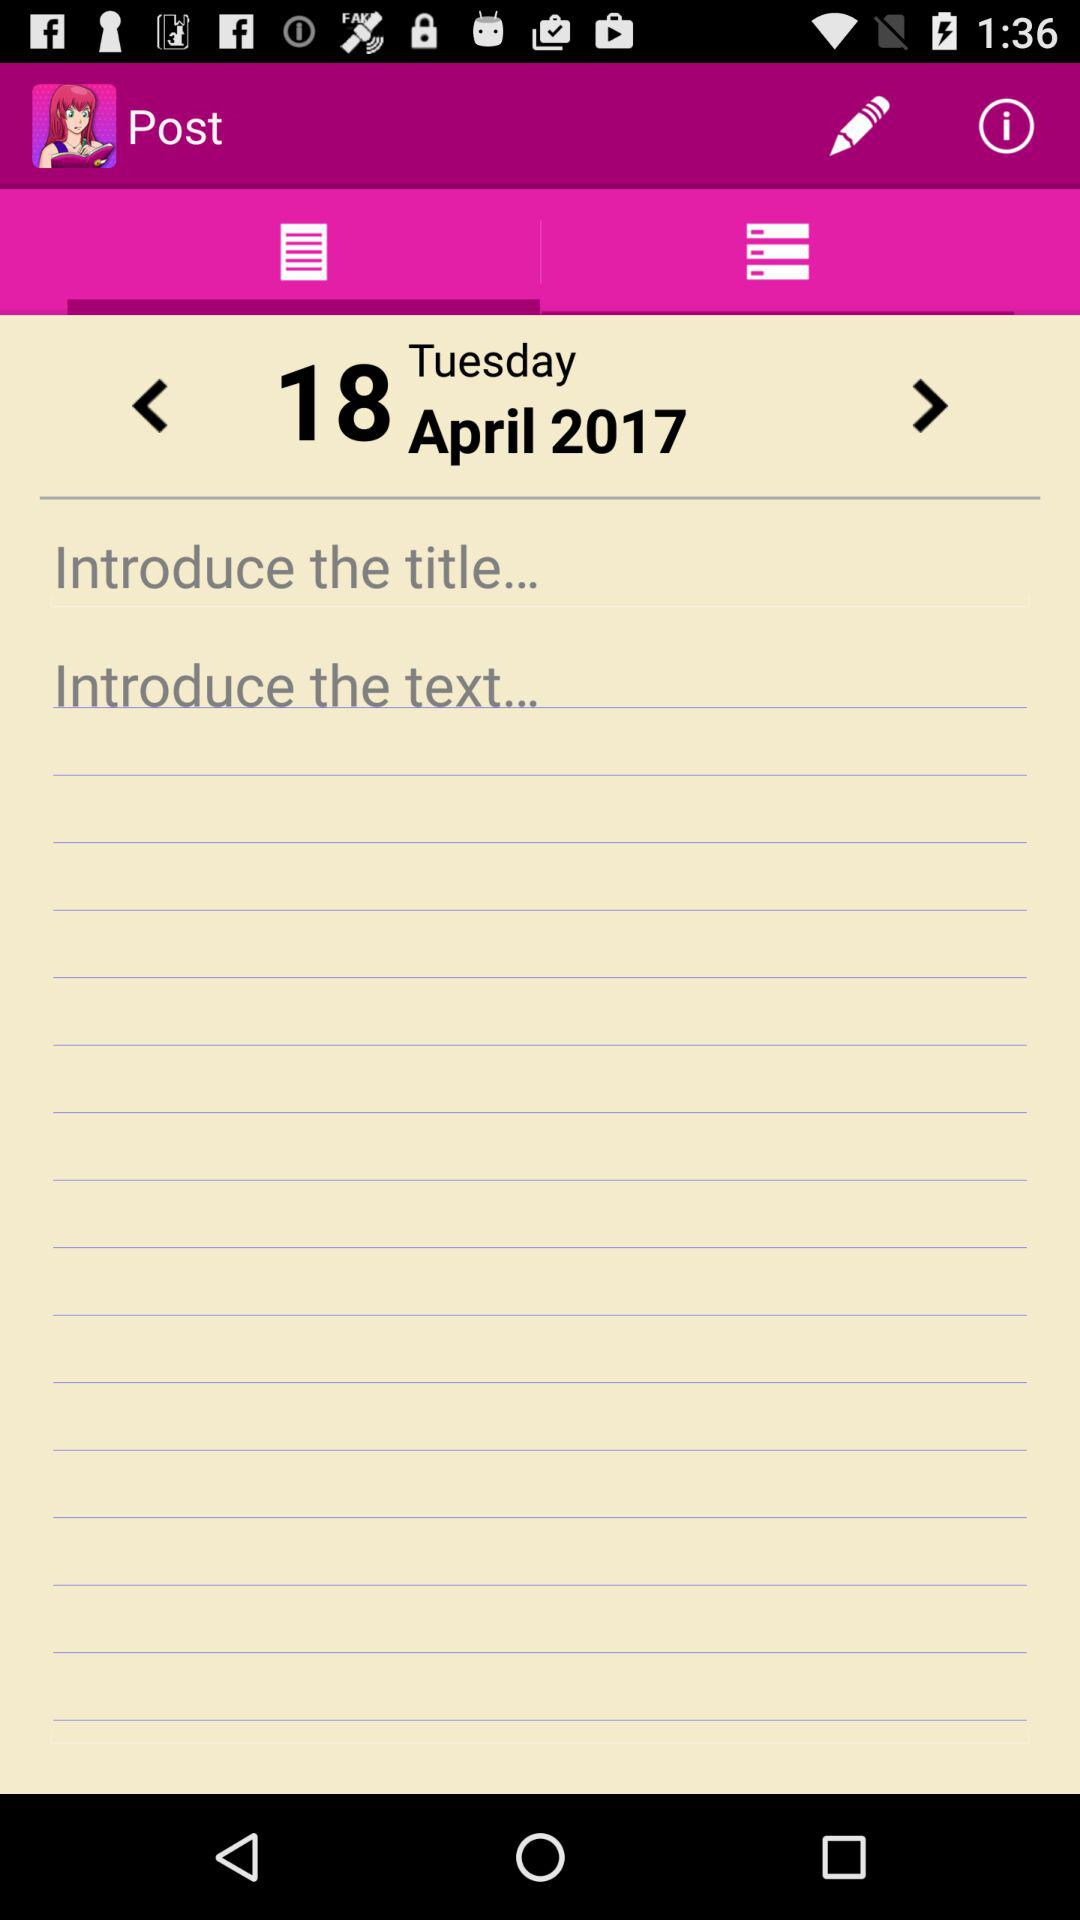What's the selected date? The selected date is Tuesday, April 18, 2017. 